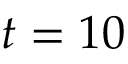Convert formula to latex. <formula><loc_0><loc_0><loc_500><loc_500>{ t } = 1 0</formula> 